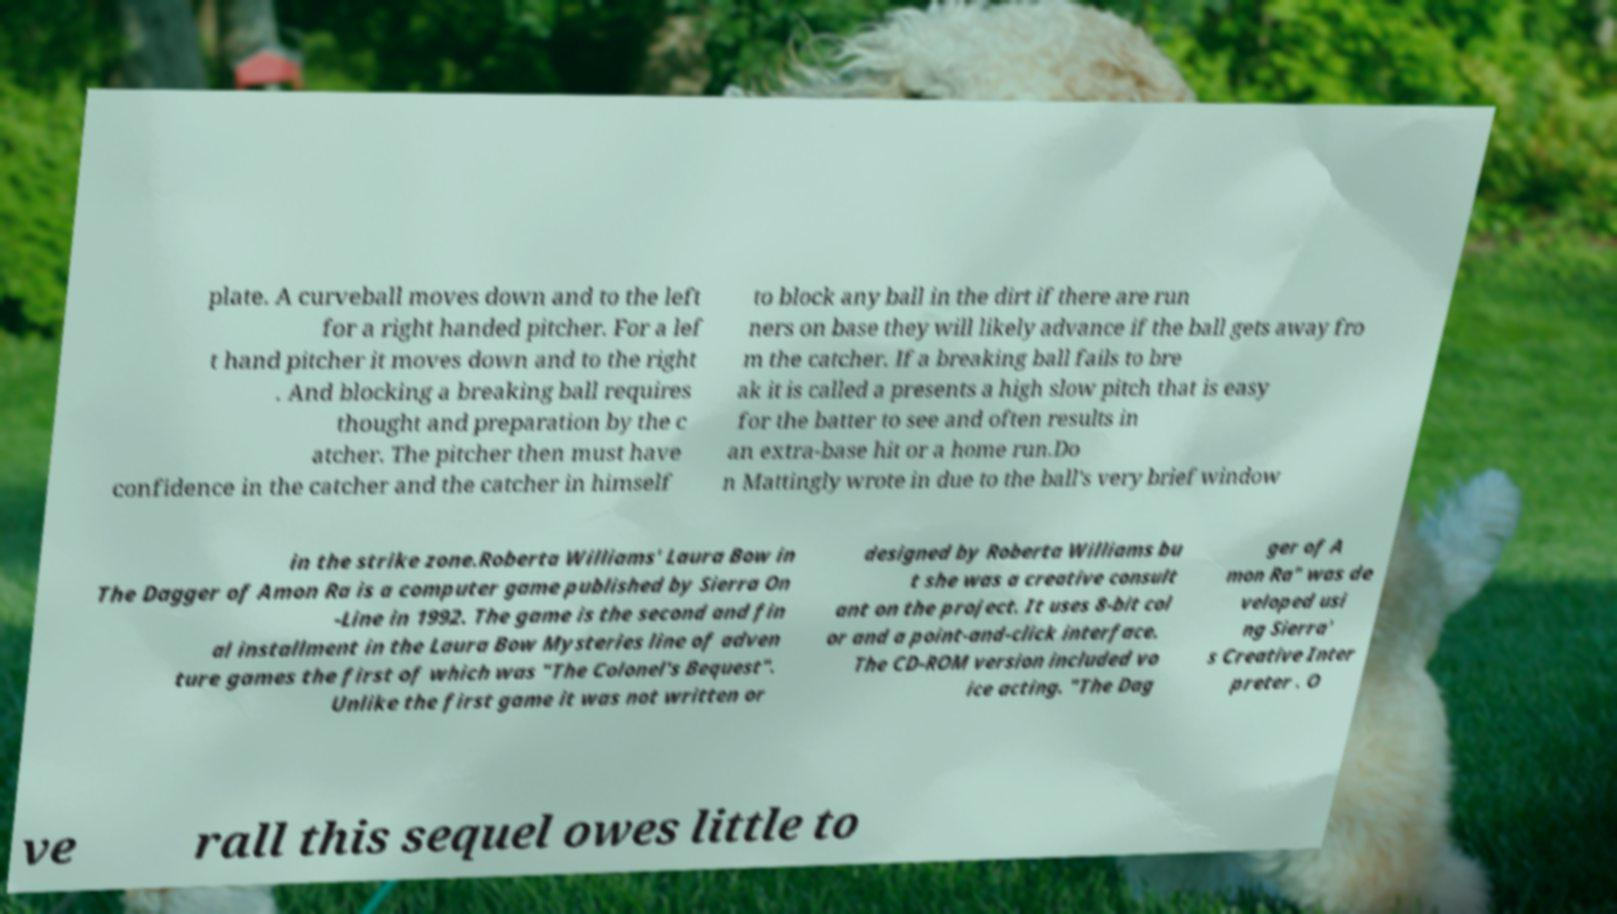Please read and relay the text visible in this image. What does it say? plate. A curveball moves down and to the left for a right handed pitcher. For a lef t hand pitcher it moves down and to the right . And blocking a breaking ball requires thought and preparation by the c atcher. The pitcher then must have confidence in the catcher and the catcher in himself to block any ball in the dirt if there are run ners on base they will likely advance if the ball gets away fro m the catcher. If a breaking ball fails to bre ak it is called a presents a high slow pitch that is easy for the batter to see and often results in an extra-base hit or a home run.Do n Mattingly wrote in due to the ball's very brief window in the strike zone.Roberta Williams' Laura Bow in The Dagger of Amon Ra is a computer game published by Sierra On -Line in 1992. The game is the second and fin al installment in the Laura Bow Mysteries line of adven ture games the first of which was "The Colonel's Bequest". Unlike the first game it was not written or designed by Roberta Williams bu t she was a creative consult ant on the project. It uses 8-bit col or and a point-and-click interface. The CD-ROM version included vo ice acting. "The Dag ger of A mon Ra" was de veloped usi ng Sierra' s Creative Inter preter . O ve rall this sequel owes little to 